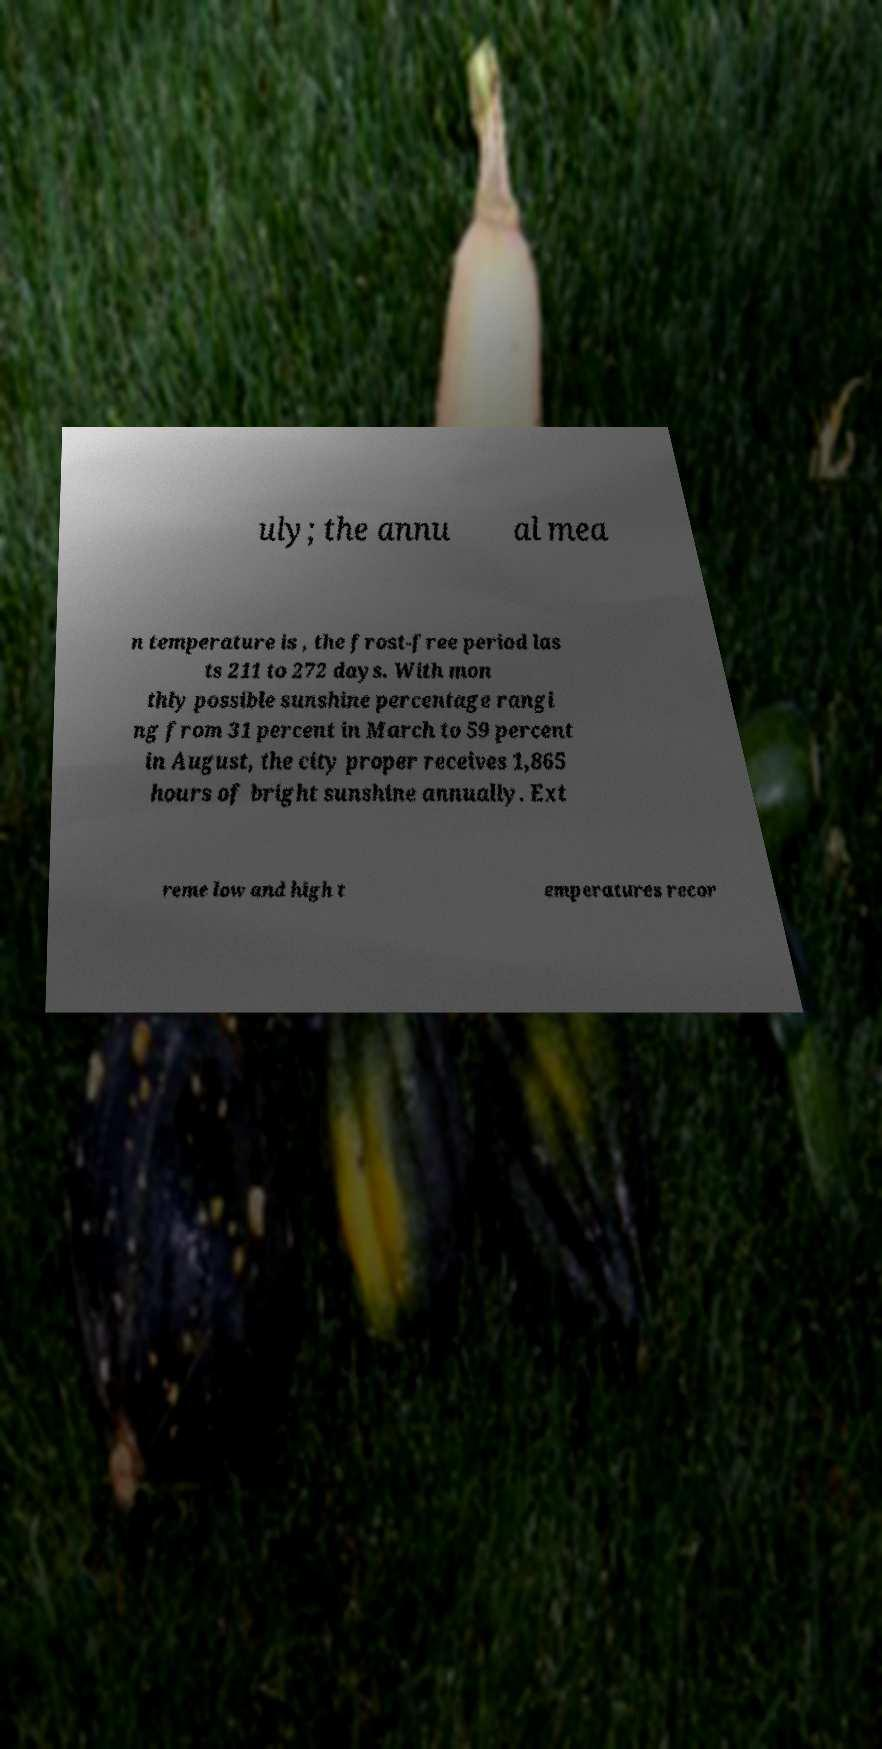Please read and relay the text visible in this image. What does it say? uly; the annu al mea n temperature is , the frost-free period las ts 211 to 272 days. With mon thly possible sunshine percentage rangi ng from 31 percent in March to 59 percent in August, the city proper receives 1,865 hours of bright sunshine annually. Ext reme low and high t emperatures recor 